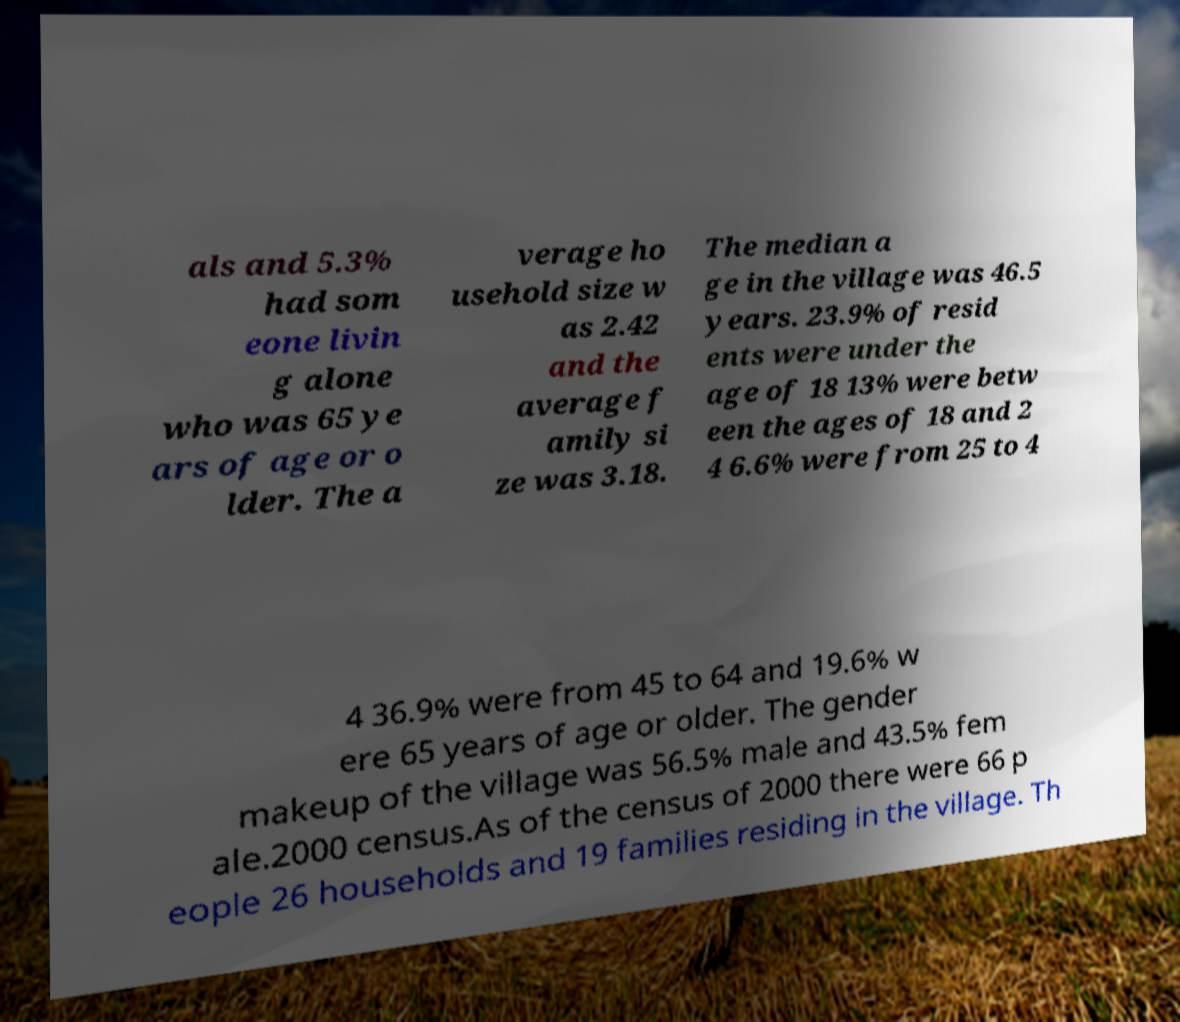I need the written content from this picture converted into text. Can you do that? als and 5.3% had som eone livin g alone who was 65 ye ars of age or o lder. The a verage ho usehold size w as 2.42 and the average f amily si ze was 3.18. The median a ge in the village was 46.5 years. 23.9% of resid ents were under the age of 18 13% were betw een the ages of 18 and 2 4 6.6% were from 25 to 4 4 36.9% were from 45 to 64 and 19.6% w ere 65 years of age or older. The gender makeup of the village was 56.5% male and 43.5% fem ale.2000 census.As of the census of 2000 there were 66 p eople 26 households and 19 families residing in the village. Th 